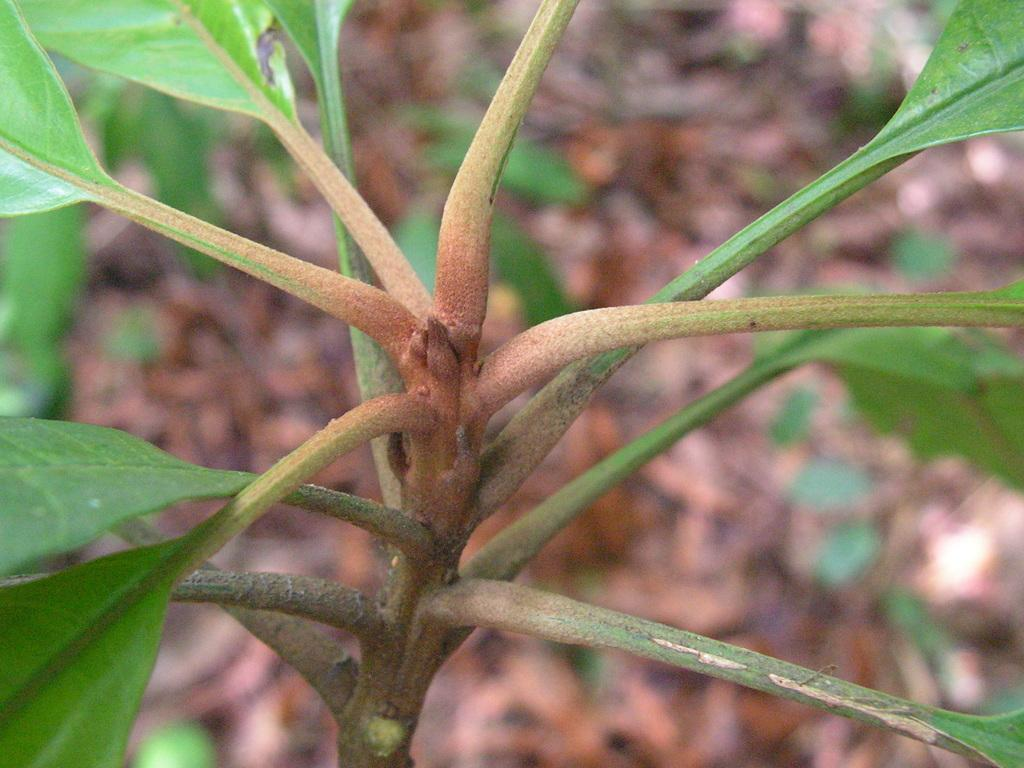What is the main subject in the center of the image? There is a plant in the center of the image. How many men are working in the cellar in the image? There is no mention of a cellar or men in the image; it only features a plant. 